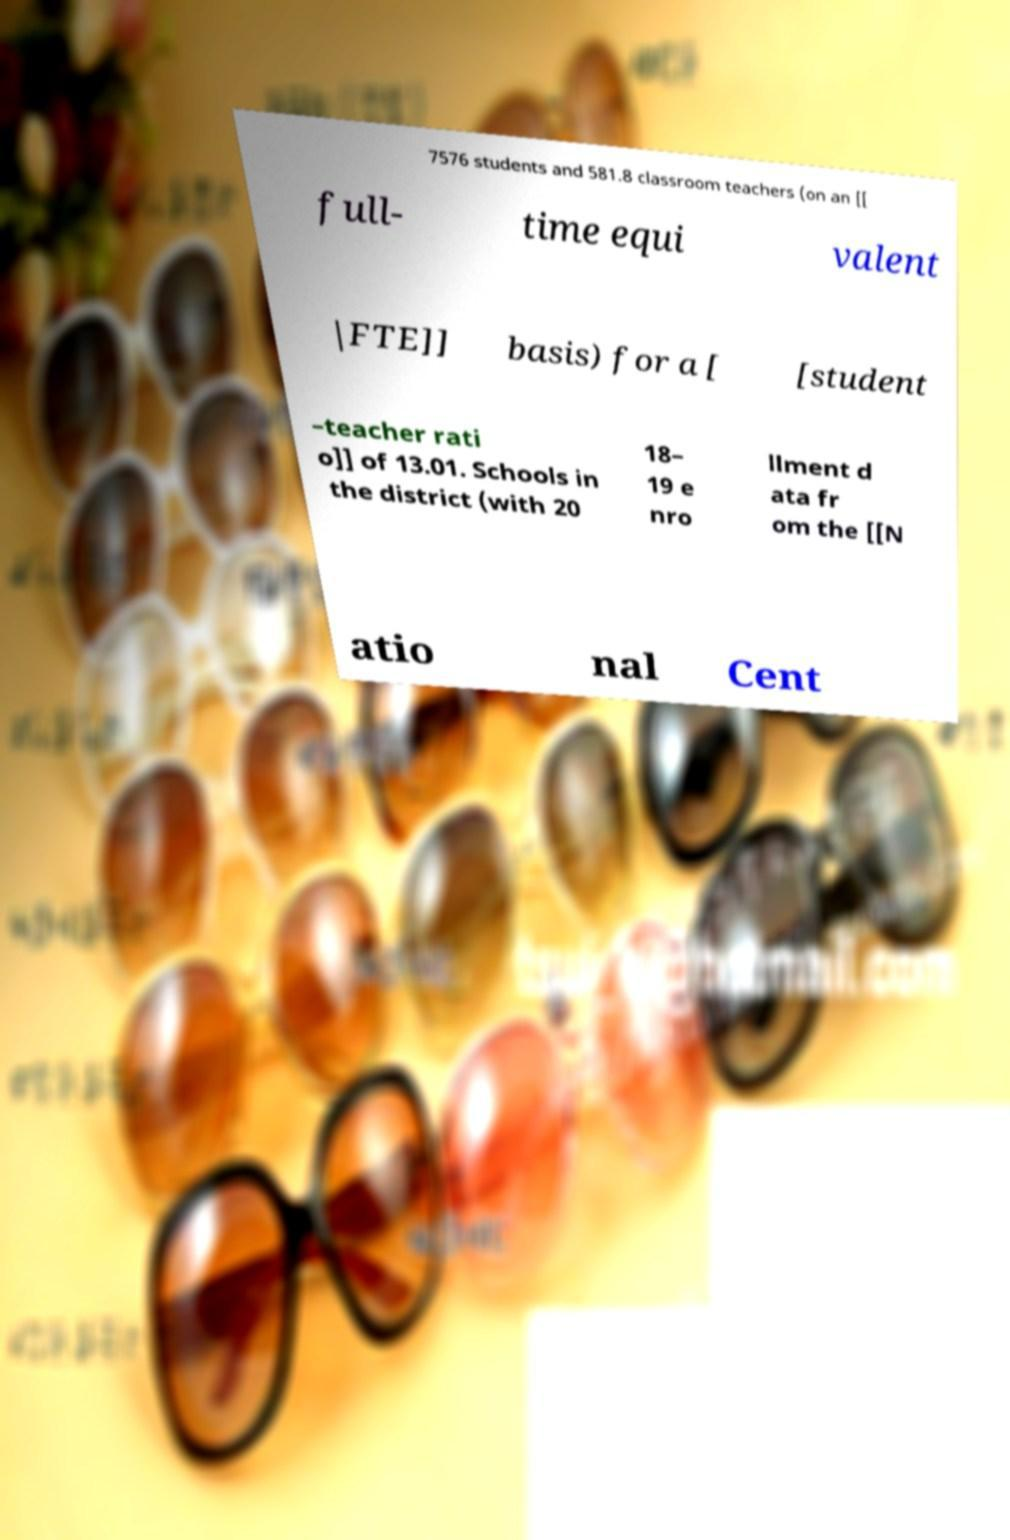There's text embedded in this image that I need extracted. Can you transcribe it verbatim? 7576 students and 581.8 classroom teachers (on an [[ full- time equi valent |FTE]] basis) for a [ [student –teacher rati o]] of 13.01. Schools in the district (with 20 18– 19 e nro llment d ata fr om the [[N atio nal Cent 